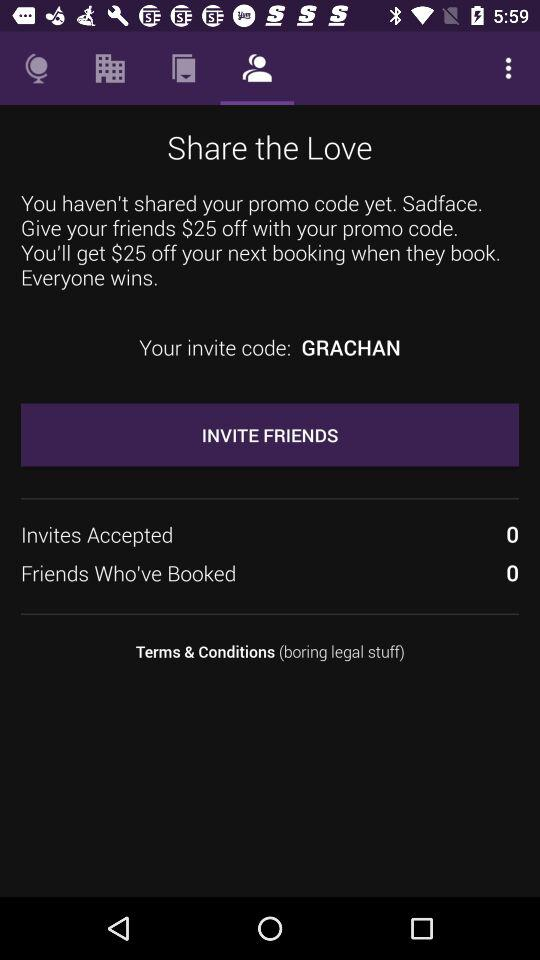What is the count of "Friends Who've Booked"? The count is 0. 